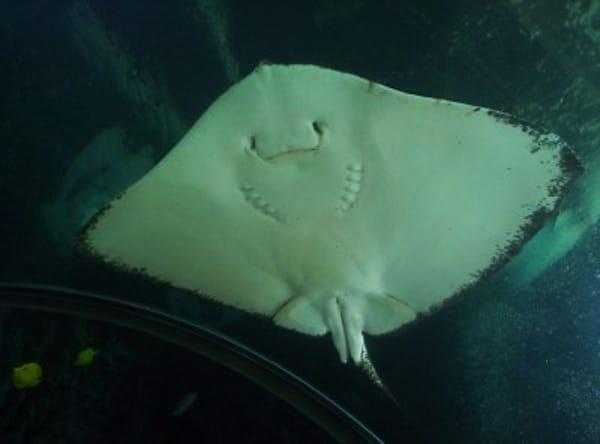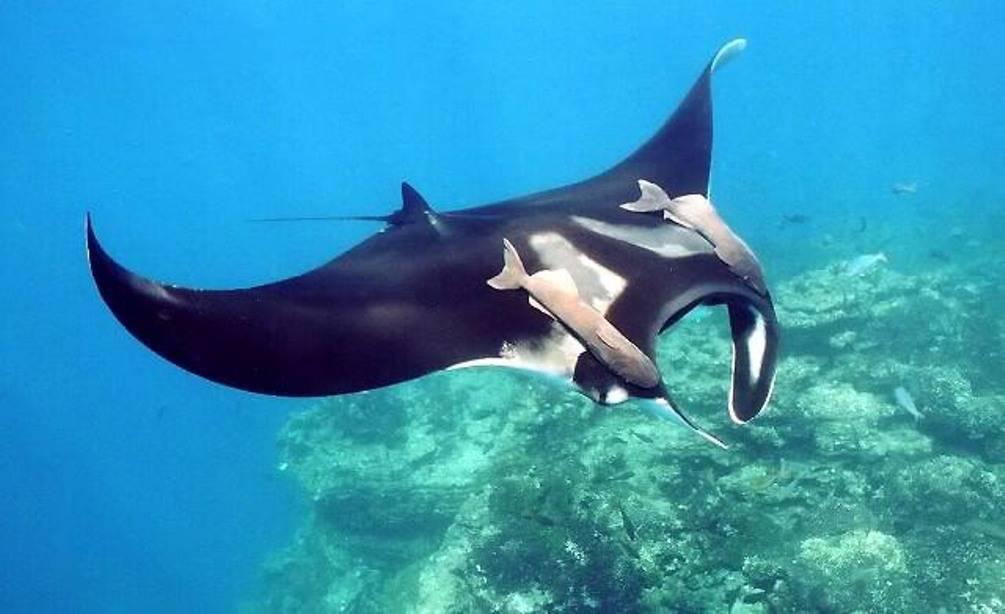The first image is the image on the left, the second image is the image on the right. For the images shown, is this caption "The creature in the image on the left appears to be smiling." true? Answer yes or no. Yes. 